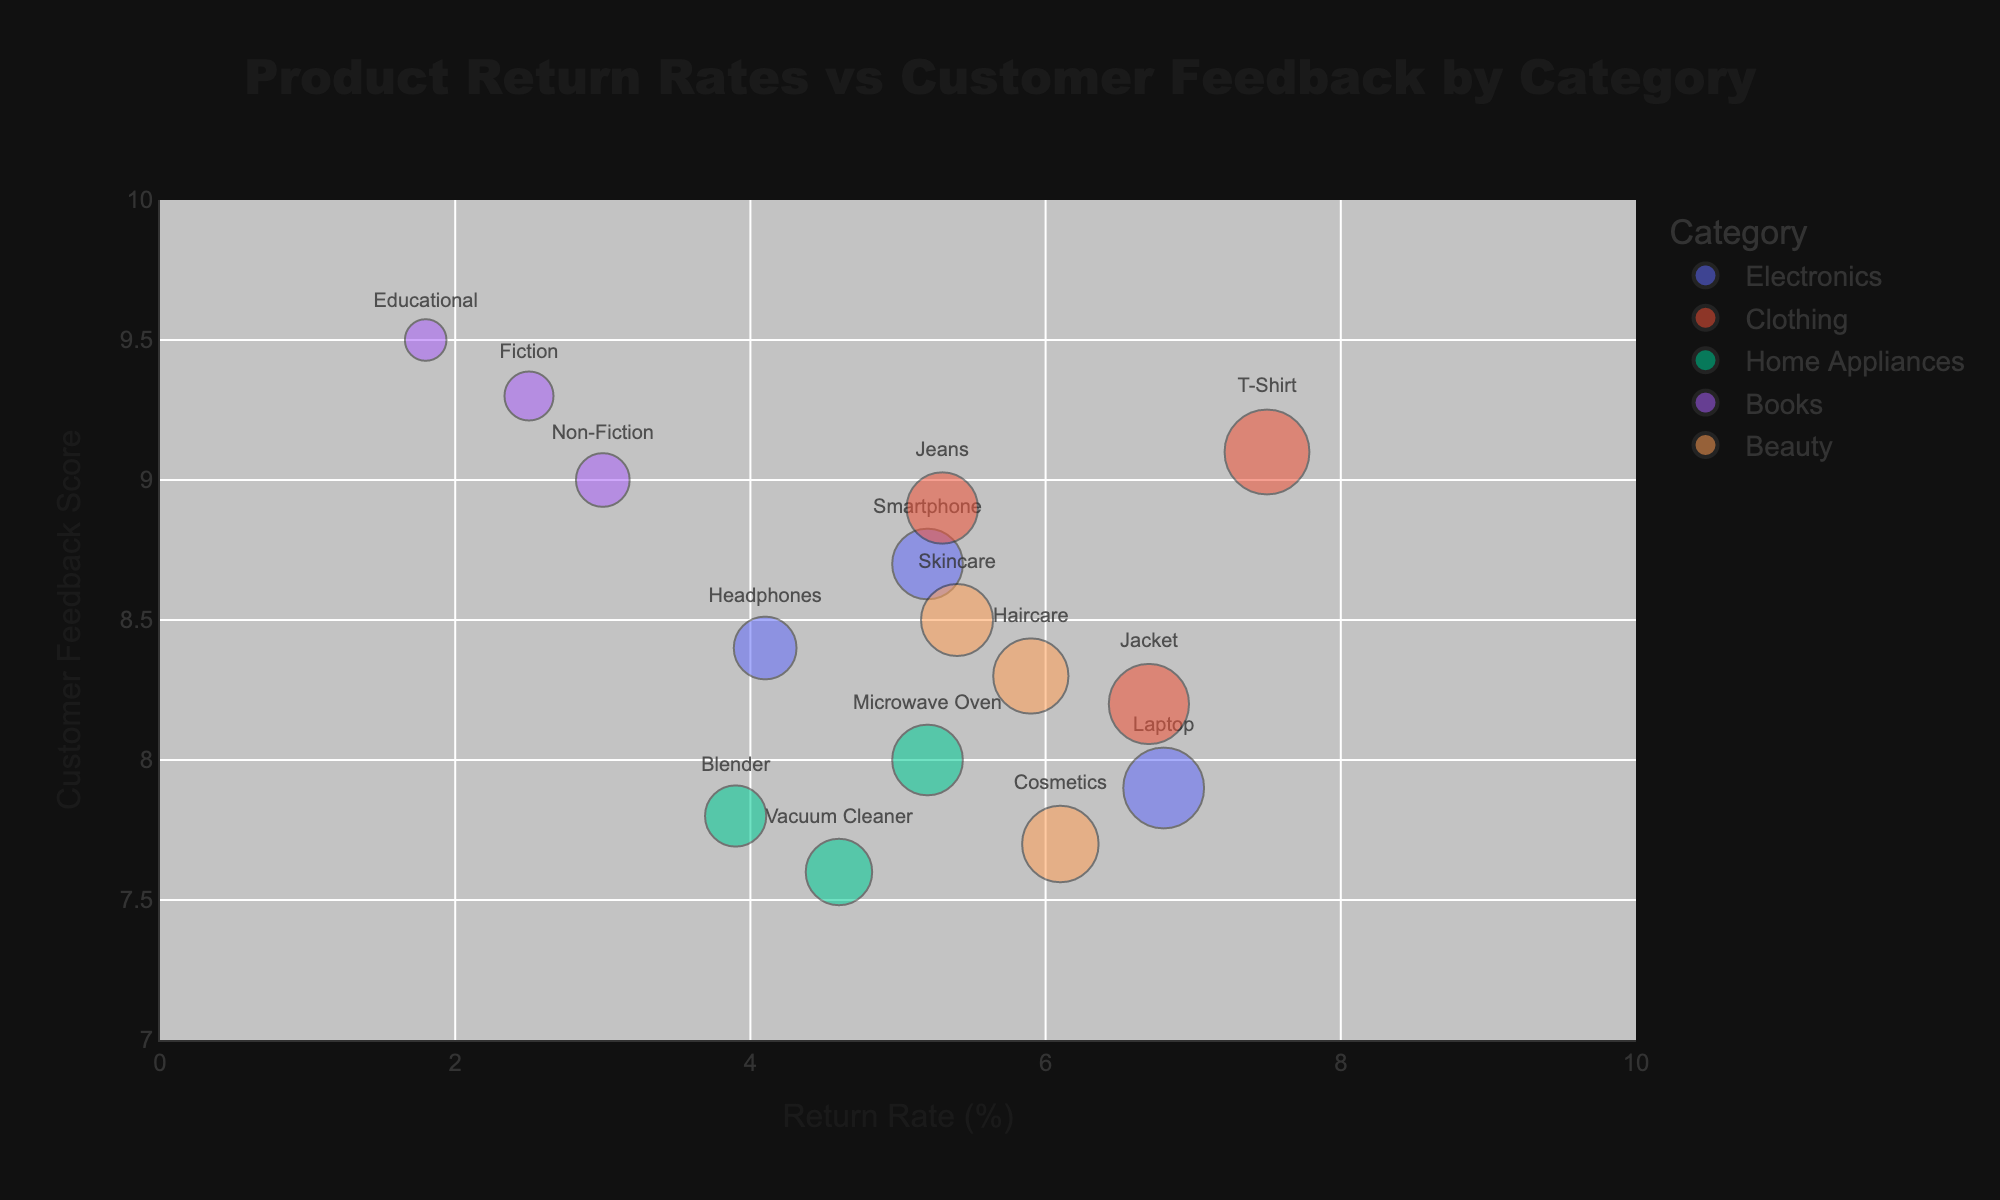What is the title of the chart? The title is located at the top center of the chart and is usually the largest text. The title for this chart is "Product Return Rates vs Customer Feedback by Category".
Answer: Product Return Rates vs Customer Feedback by Category What are the x-axis and y-axis titles? The axis titles are located next to the respective axes. The x-axis title is "Return Rate (%)" and the y-axis title is "Customer Feedback Score".
Answer: Return Rate (%) and Customer Feedback Score How many categories are represented in the chart? The distinct categories can be identified by different bubble colors in the legend. The categories in the chart are Electronics, Clothing, Home Appliances, Books, and Beauty.
Answer: Five Which product has the highest Customer Feedback Score? Look for the bubble positioned highest on the y-axis, indicating maximum Customer Feedback Score. For category Books, the product Educational has the highest score at 9.5.
Answer: Educational Which category has the highest average Return Rate Percentage? Calculate the average return rate for each category and compare them. Clothing averages (7.5+5.3+6.7)/3 = 6.5, which is higher than the other categories.
Answer: Clothing What is the Return Rate Percentage of the product with the lowest Customer Feedback Score? Locate the bubble lowest on the y-axis. The product Cosmetics in the Beauty category has the lowest Customer Feedback Score (7.7), with a Return Rate Percentage of 6.1.
Answer: 6.1 Compare the return rates of the products with the names written on the chart (excluding hover text). Look for the bubbles with visible text; each text represents a product. For these products, T-Shirt has a 7.5 return rate and Laptop has a 6.8 return rate.
Answer: T-Shirt has higher return rate than Laptop Which product has the smallest bubble size, and what is its return rate? In a bubble chart, the smallest bubble represents the smallest size value. In this chart, Educational in Books is the smallest bubble with a return rate of 1.8%.
Answer: Educational, 1.8 How does the return rate of Smartphones compare with that of Blenders? Find and compare their locations on the x-axis. The Smartphone (Electronics) return rate is 5.2% and Blender (Home Appliances) is 3.9%.
Answer: Smartphone has a higher return rate than Blender Which category has the lowest average Customer Feedback Score? Calculate the average Customer Feedback Score for each category and compare. Beauty scores (7.7+8.5+8.3)/3 = 8.17, which is the lowest among the categories.
Answer: Beauty 